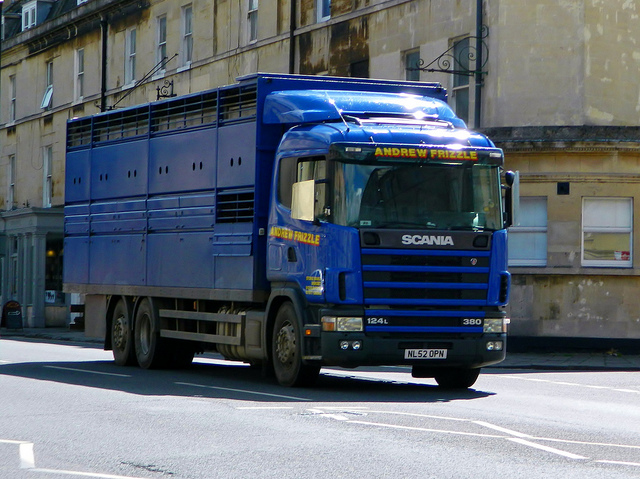Read and extract the text from this image. FRIZZLE SCANIA ANDREW FRIZZLE OPN 52 NL 380 